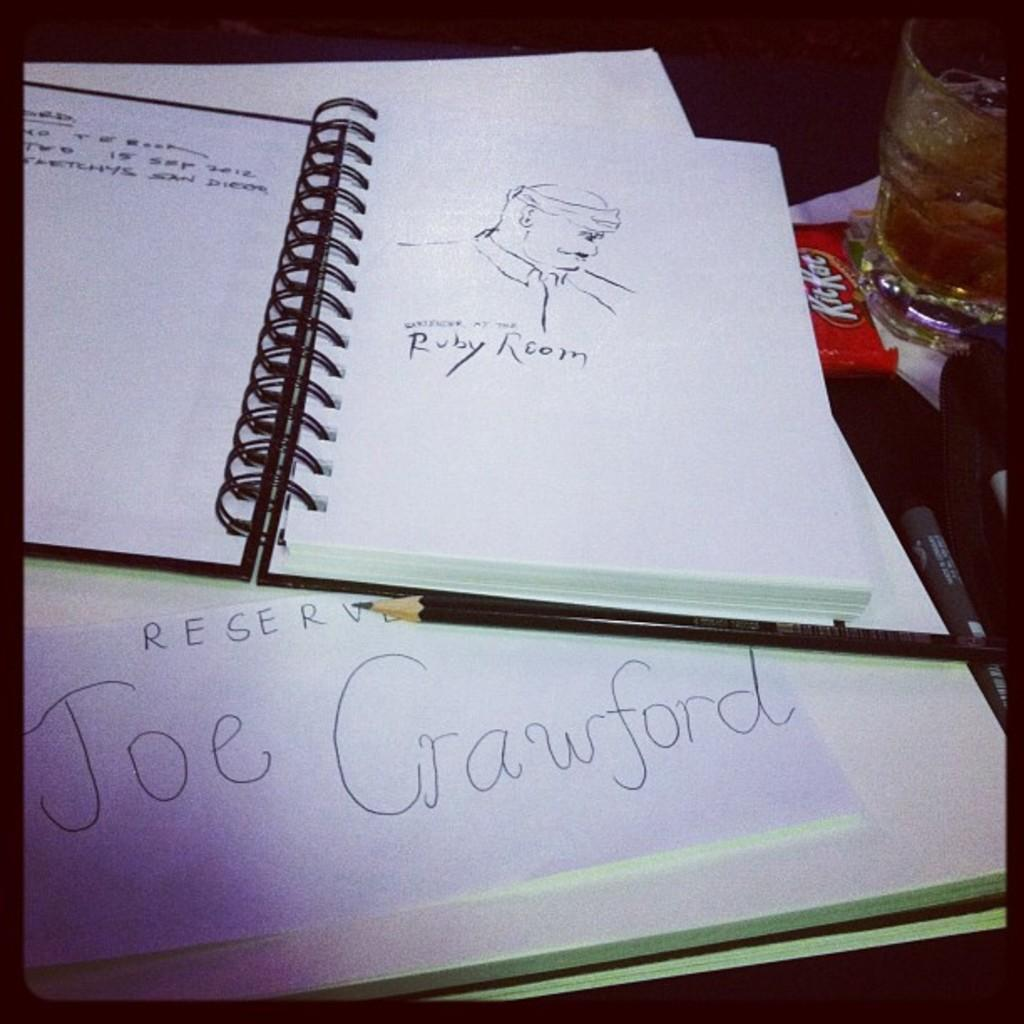<image>
Provide a brief description of the given image. the name Joe is on a white piece of paper 